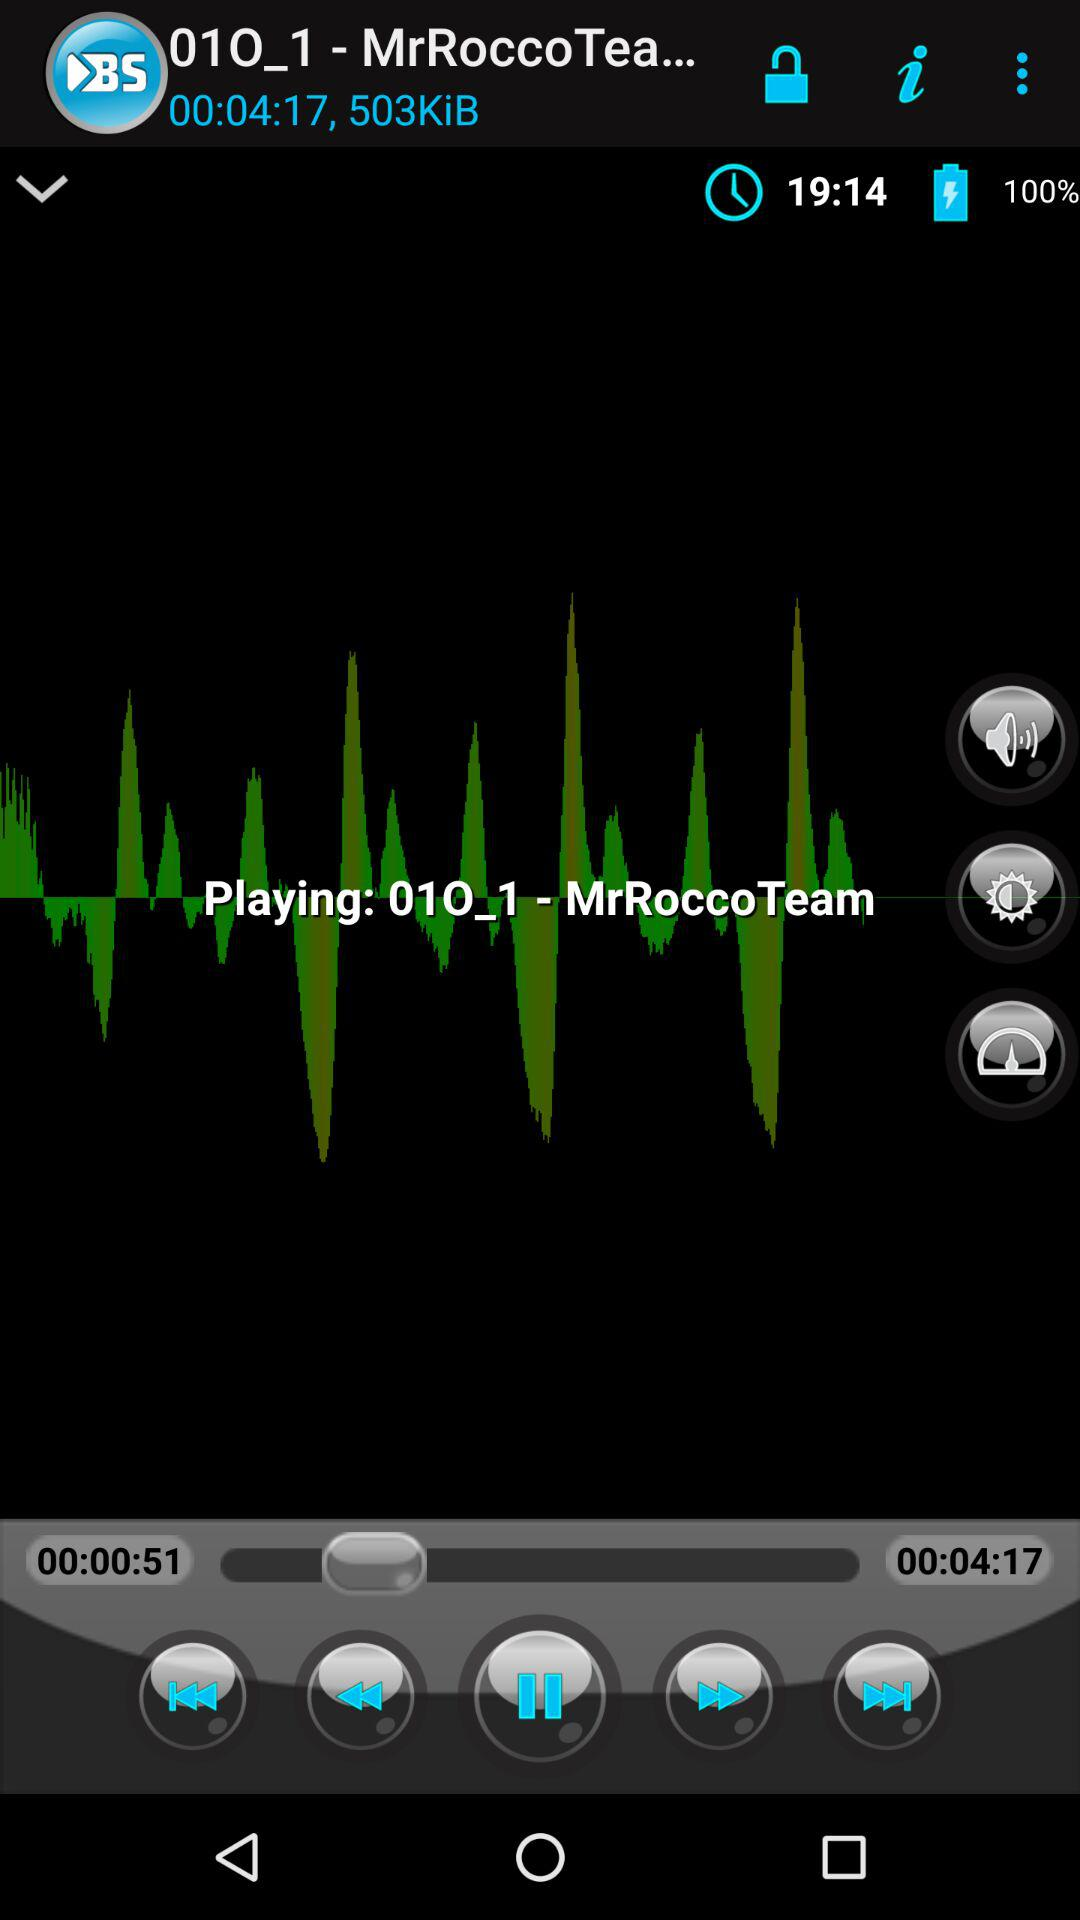What is the duration of the song? The duration of the song is 00:04:17. 